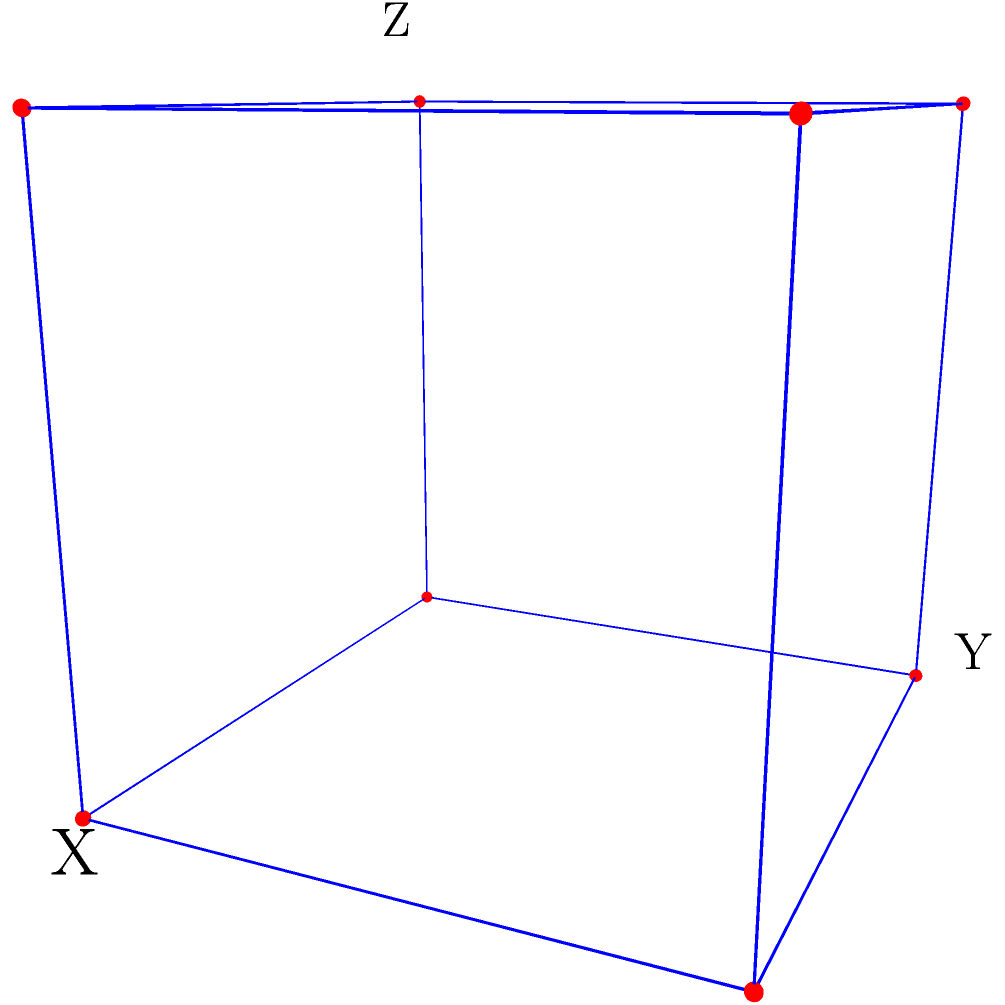Given the hypercube structure shown above, which is a projection of a 4D hypercube into 3D space, how many edges would the full 4D hypercube have in total? Consider this in the context of designing an interconnection network for parallel computing in our university's supercomputer facility. To determine the number of edges in a 4D hypercube, let's follow these steps:

1. Recall that a hypercube of dimension $n$ has $2^n$ vertices.
   For a 4D hypercube, $n = 4$, so there are $2^4 = 16$ vertices.

2. In a hypercube, each vertex is connected to exactly $n$ other vertices.
   In our 4D case, each vertex connects to 4 others.

3. The total number of edges can be calculated using the formula:
   $\text{Number of edges} = \frac{n \cdot 2^n}{2}$

4. This formula accounts for the fact that each edge is counted twice 
   (once from each of its endpoints) in the $n \cdot 2^n$ term.

5. Substituting $n = 4$ into our formula:
   $\text{Number of edges} = \frac{4 \cdot 2^4}{2} = \frac{4 \cdot 16}{2} = 32$

6. We can verify this result:
   - The 3D projection shows 12 edges
   - Each of the 8 vertices in the 3D projection would have one additional edge 
     connecting to its 4D counterpart
   - This adds 8 more edges, totaling 20 edges visible or implied in the projection
   - The remaining 12 edges connect the 4D counterparts, matching our calculation

This 32-edge structure provides a highly connected network topology, allowing for efficient parallel processing in the supercomputer by minimizing the number of hops between nodes.
Answer: 32 edges 